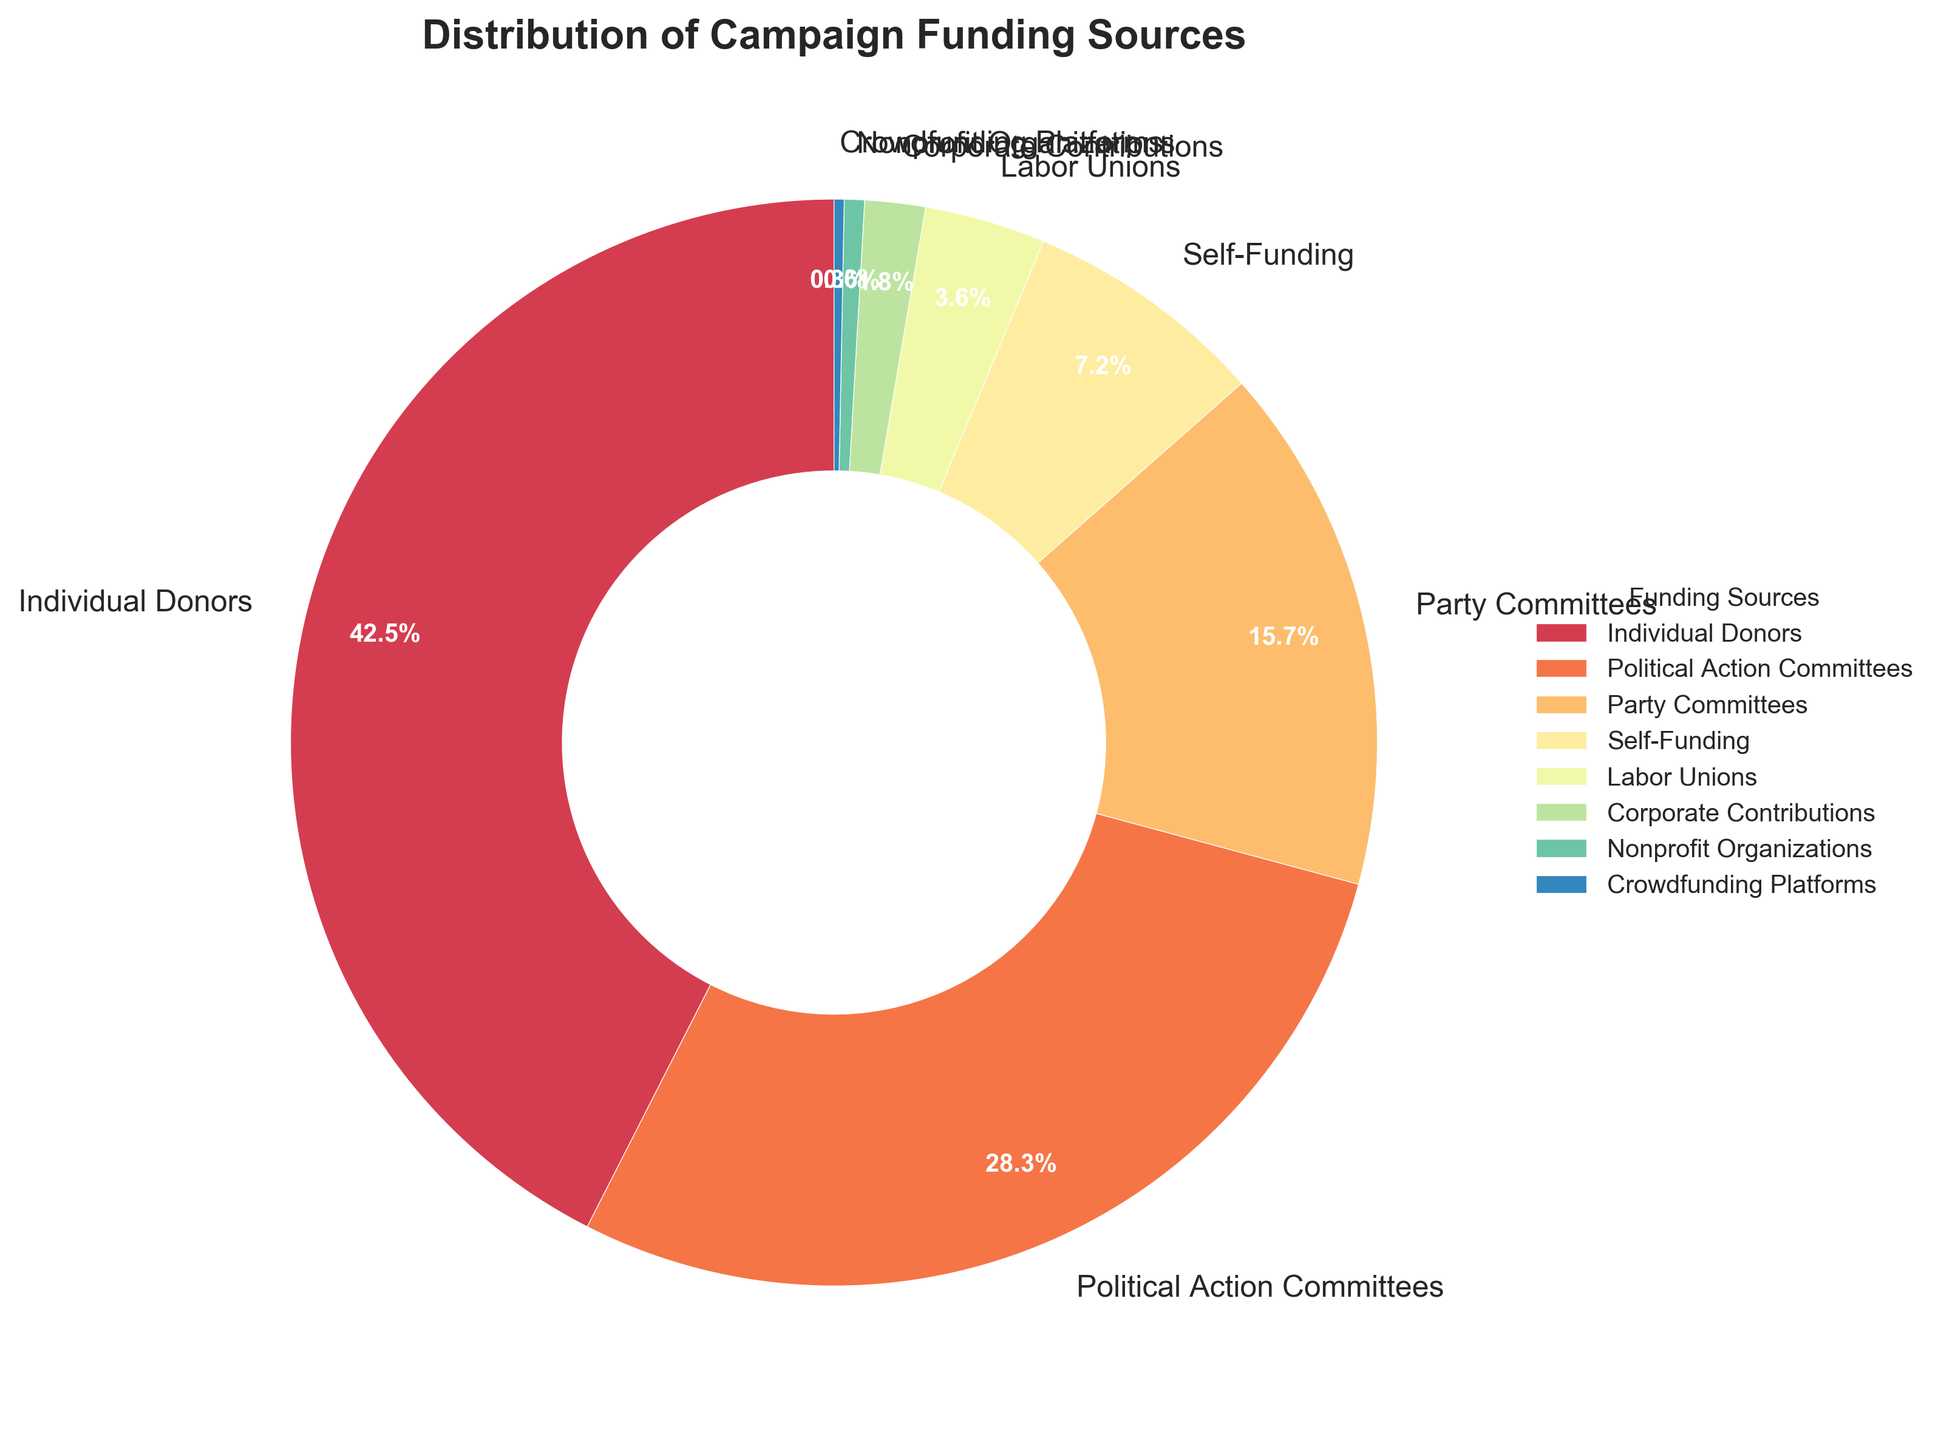What percentage of campaign funding comes from Political Action Committees? According to the pie chart, the segment labeled "Political Action Committees" represents their contribution. The percentage listed next to this segment is 28.3%.
Answer: 28.3% Which funding source contributes the least to campaign funding? The pie chart shows the smallest segment labeled "Crowdfunding Platforms" with a percentage of 0.3%, indicating it is the smallest contribution.
Answer: Crowdfunding Platforms What is the combined percentage contribution of Individual Donors and Party Committees? To find the combined contribution, add the percentages of Individual Donors (42.5%) and Party Committees (15.7%): 42.5% + 15.7% = 58.2%.
Answer: 58.2% Which funding source contributes more, Self-Funding or Labor Unions, and by how much? To compare their contributions, look at Self-Funding (7.2%) and Labor Unions (3.6%). Subtract the smaller percentage from the larger: 7.2% - 3.6% = 3.6%.
Answer: Self-Funding by 3.6% Are there more funding sources contributing greater than 10% or less than 10% of the total campaign funding? Examine the pie chart segments and their respective percentages. Greater than 10%: Individual Donors (42.5%), Political Action Committees (28.3%), and Party Committees (15.7%). Less than 10%: Self-Funding (7.2%), Labor Unions (3.6%), Corporate Contributions (1.8%), Nonprofit Organizations (0.6%), Crowdfunding Platforms (0.3%). There are 3 sources greater than 10% and 5 sources less than 10%.
Answer: Less than 10% What visual attribute signifies the contributions from Corporate Contributions compared to Nonprofit Organizations? Looking at the pie chart, Corporate Contributions and Nonprofit Organizations are differentiated by the size of their slices. Corporate Contributions is larger with 1.8%, while Nonprofit Organizations is smaller with 0.6%.
Answer: Larger slice What is the range of percentage contributions among all the funding sources? The range is determined by subtracting the smallest percentage (Crowdfunding Platforms, 0.3%) from the largest percentage (Individual Donors, 42.5%): 42.5% - 0.3% = 42.2%.
Answer: 42.2% What is the total contribution percentage of all funding sources combined? Since the pie chart represents the whole (100%), summing all contributions of individual segments should give 100%. Sum: 42.5 + 28.3 + 15.7 + 7.2 + 3.6 + 1.8 + 0.6 + 0.3 = 100%.
Answer: 100% Is the contribution from Nonprofit Organizations greater than Corporate Contributions? Examine the pie chart segments for Nonprofit Organizations (0.6%) and Corporate Contributions (1.8%). Nonprofit Organizations have a smaller percentage than Corporate Contributions.
Answer: No Which slice indicates the largest funding source, and what is its percentage? The largest slice in the pie chart is labeled "Individual Donors" and has a percentage of 42.5%.
Answer: Individual Donors with 42.5% 